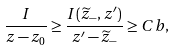<formula> <loc_0><loc_0><loc_500><loc_500>\frac { I } { z - z _ { 0 } } \geq \frac { I ( \widetilde { z } _ { - } , z ^ { \prime } ) } { z ^ { \prime } - \widetilde { z } _ { - } } \geq C b ,</formula> 